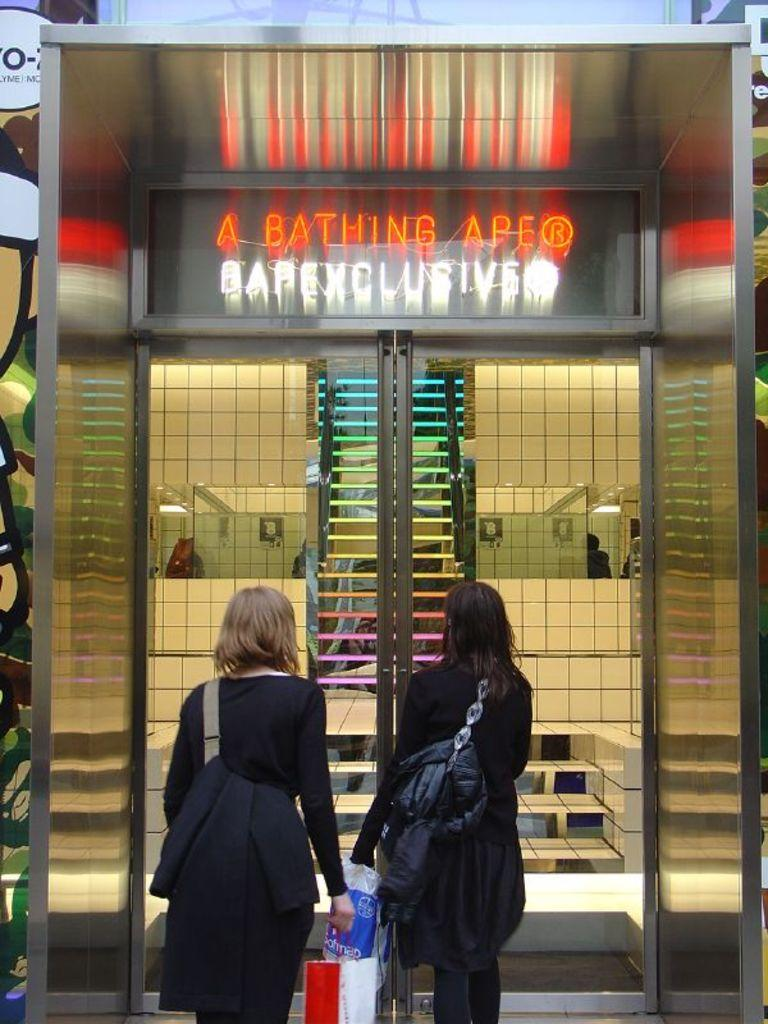How many people are in the image? There are people in the image. What can be seen in the background of the image? There is a door, steps, tile walls, and a digital board in the image. What objects are the two people in the front holding? Two people are holding objects in the front of the image. What type of objects are the people holding? Unfortunately, the specific objects cannot be determined from the provided facts. What does the father say to the self in the image? There is no mention of a father or self in the image, so it is not possible to answer this question. 